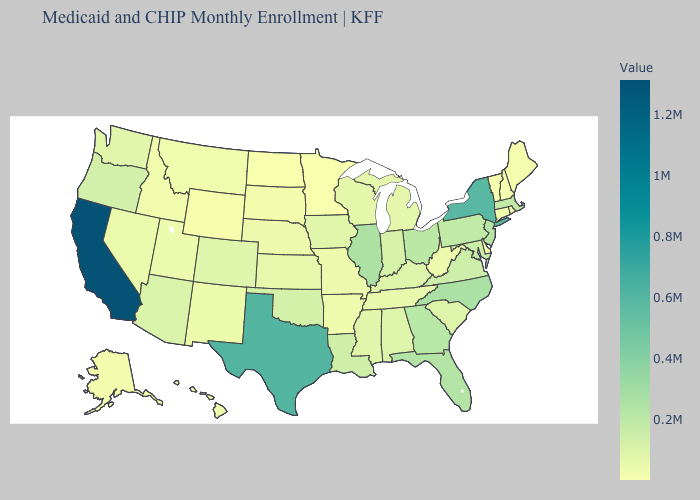Does Illinois have the highest value in the MidWest?
Write a very short answer. Yes. Is the legend a continuous bar?
Concise answer only. Yes. Does North Dakota have a higher value than Massachusetts?
Be succinct. No. Does Illinois have the highest value in the MidWest?
Answer briefly. Yes. Does Minnesota have the lowest value in the USA?
Be succinct. Yes. Does Nevada have the lowest value in the West?
Keep it brief. No. Does California have the highest value in the West?
Keep it brief. Yes. Which states have the lowest value in the MidWest?
Give a very brief answer. Minnesota. 